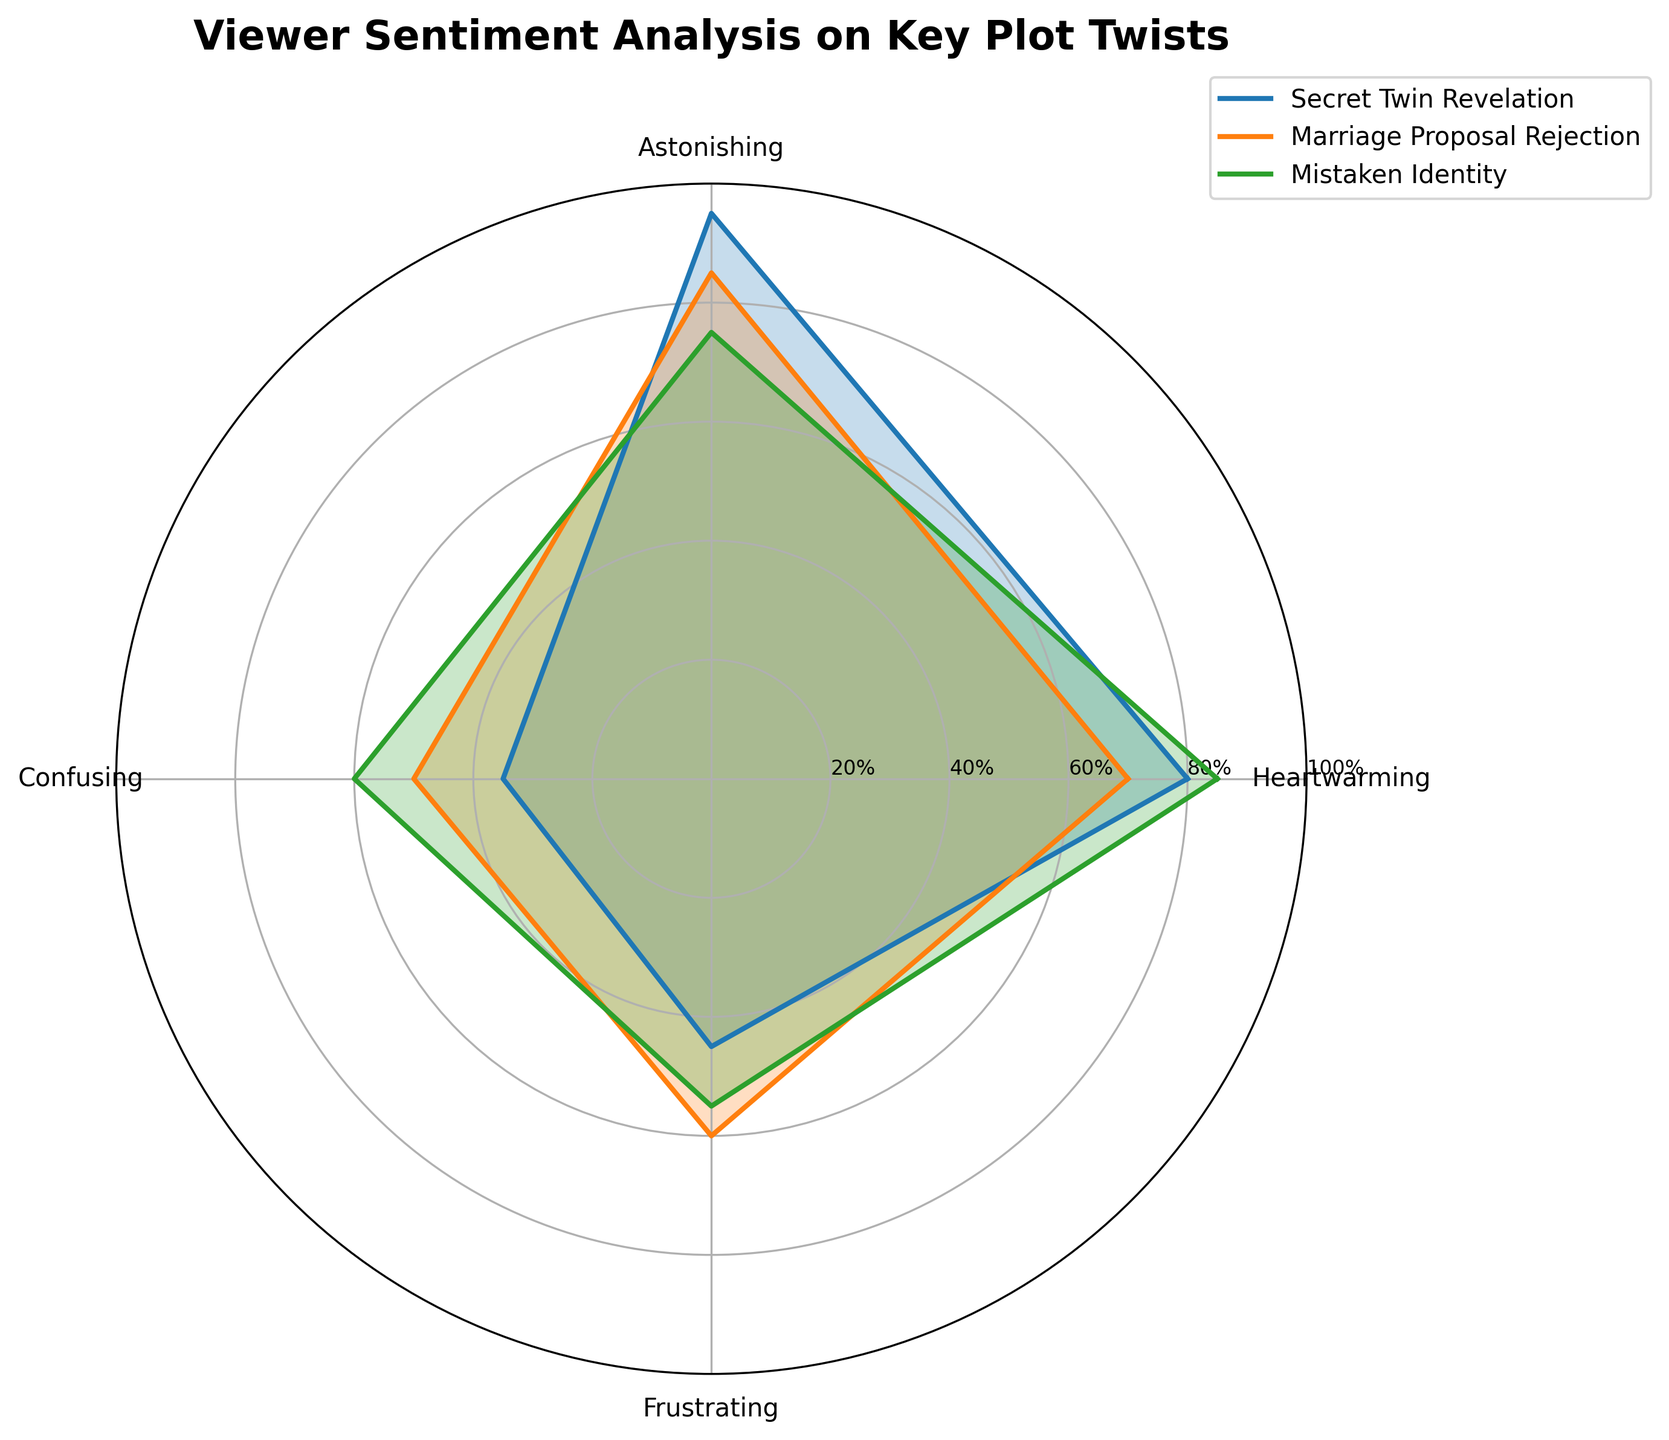What's the title of the radar chart? The title is typically written at the top of the radar chart.
Answer: Viewer Sentiment Analysis on Key Plot Twists How many plot twists are displayed in the chart? Each plot twist corresponds to a line and shading on the radar chart. Counting the lines and shadings tells us how many twists are displayed.
Answer: 3 Which plot twist received the highest "Heartwarming" sentiment? By checking the "Heartwarming" axis, look for the line that extends the farthest from the center.
Answer: Lost Letter Discovery Which sentiment category is rated the lowest overall across all plot twists? To find the lowest overall rating, we check the minimum values across each sentiment category on the radar chart.
Answer: Confusing For "Marriage Proposal Rejection", which sentiment has the highest score? Look at the values for "Marriage Proposal Rejection" and identify the highest point on the radar chart for this plot twist.
Answer: Astonishing Which plot twist has the largest difference between "Heartwarming" and "Confusing" sentiments? Check each plot twist's "Heartwarming" and "Confusing" scores, then calculate the differences and compare them. Mistaken Identity has Heartwarming (85) - Confusing (60) = 25, which is the largest difference.
Answer: Mistaken Identity Compare "Heartwarming" and "Frustrating" sentiments for "Secret Twin Revelation". Which is higher, and by how much? Identify the points for "Heartwarming" and "Frustrating" for "Secret Twin Revelation" and subtract the smaller from the larger value. Heartwarming (80) and Frustrating (45) gives 80 - 45.
Answer: Heartwarming by 35 Which plot twist shows the most balanced sentiment scores? A balanced twist would have similar values across all sentiment categories.
Answer: Mistaken Identity What’s the average "Astonishing" sentiment score across the three plot twists? Add the "Astonishing" scores for the three plot twists and divide by 3. (95 + 85 + 75) / 3 = 85
Answer: 85 Which plot twist has a more concentrated sentiment towards a single category? Look for a plot twist with one sentiment significantly higher than the others. "Secret Twin Revelation" has "Astonishing" at 95, much higher than its other scores.
Answer: Secret Twin Revelation 